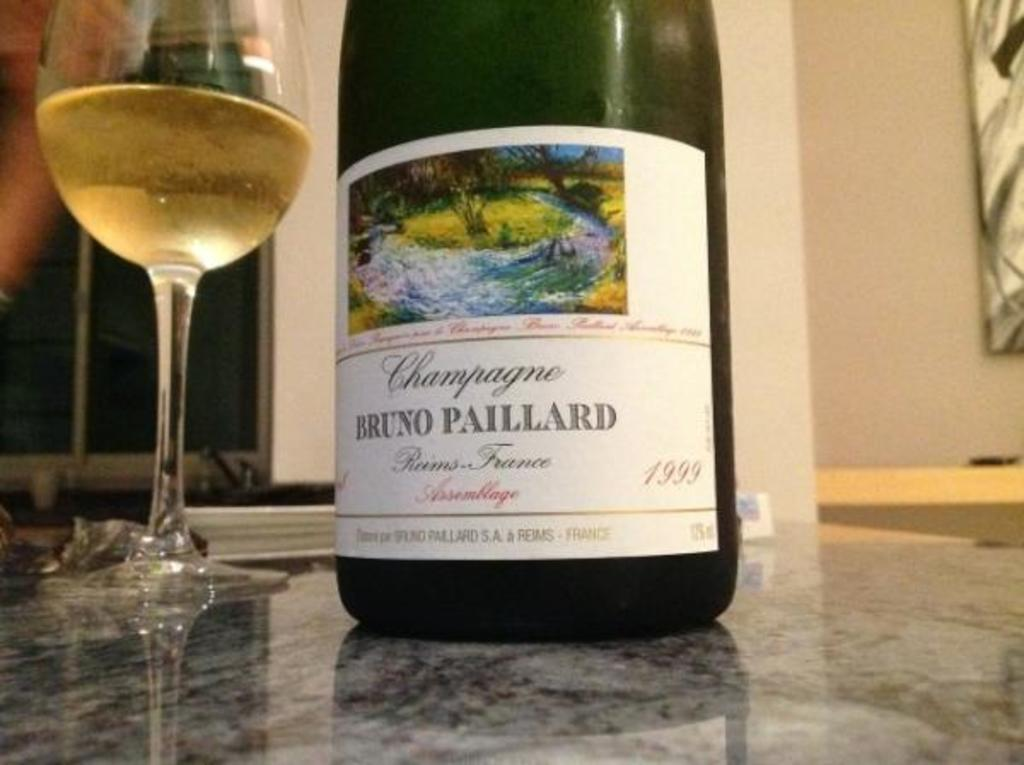<image>
Present a compact description of the photo's key features. A bottle of champagne has a Bruno Paillard label. 